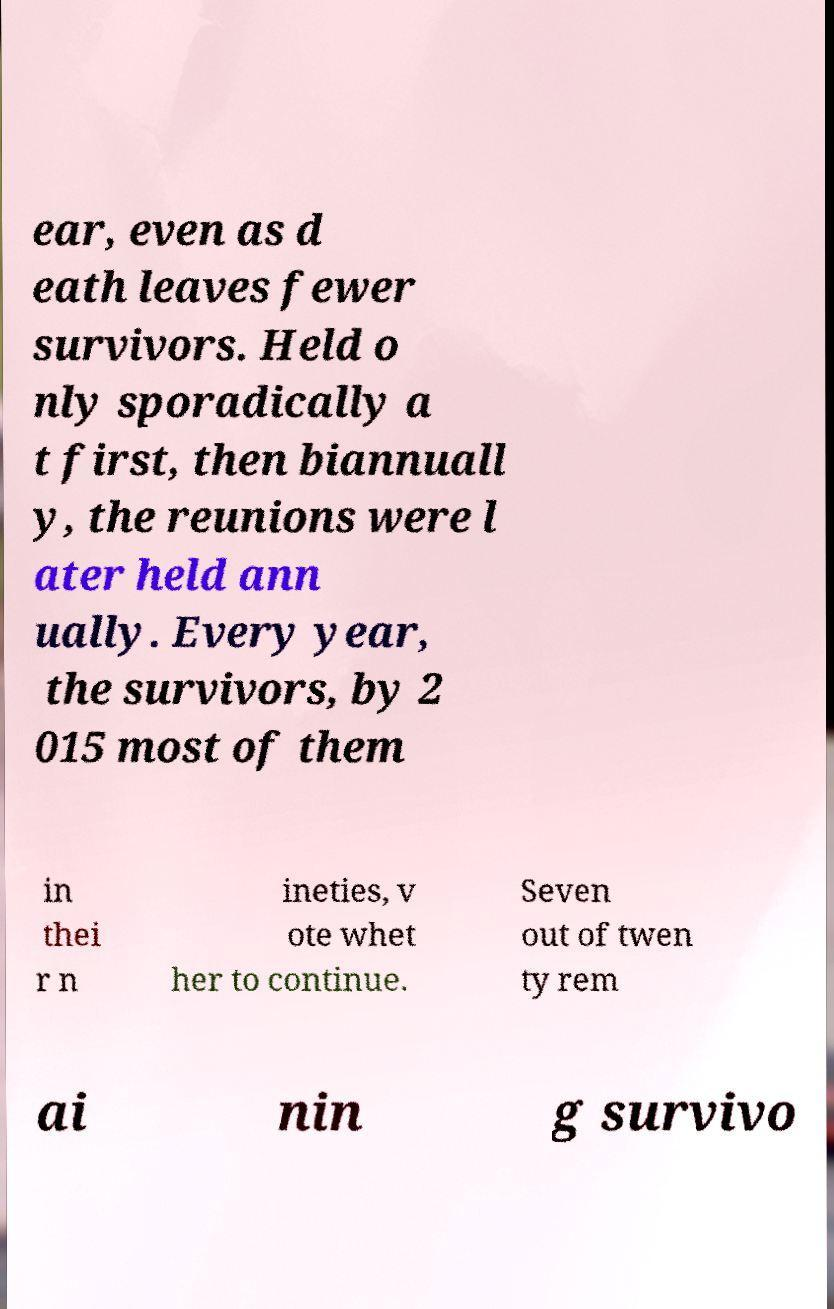Could you assist in decoding the text presented in this image and type it out clearly? ear, even as d eath leaves fewer survivors. Held o nly sporadically a t first, then biannuall y, the reunions were l ater held ann ually. Every year, the survivors, by 2 015 most of them in thei r n ineties, v ote whet her to continue. Seven out of twen ty rem ai nin g survivo 